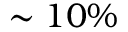<formula> <loc_0><loc_0><loc_500><loc_500>\sim 1 0 \%</formula> 